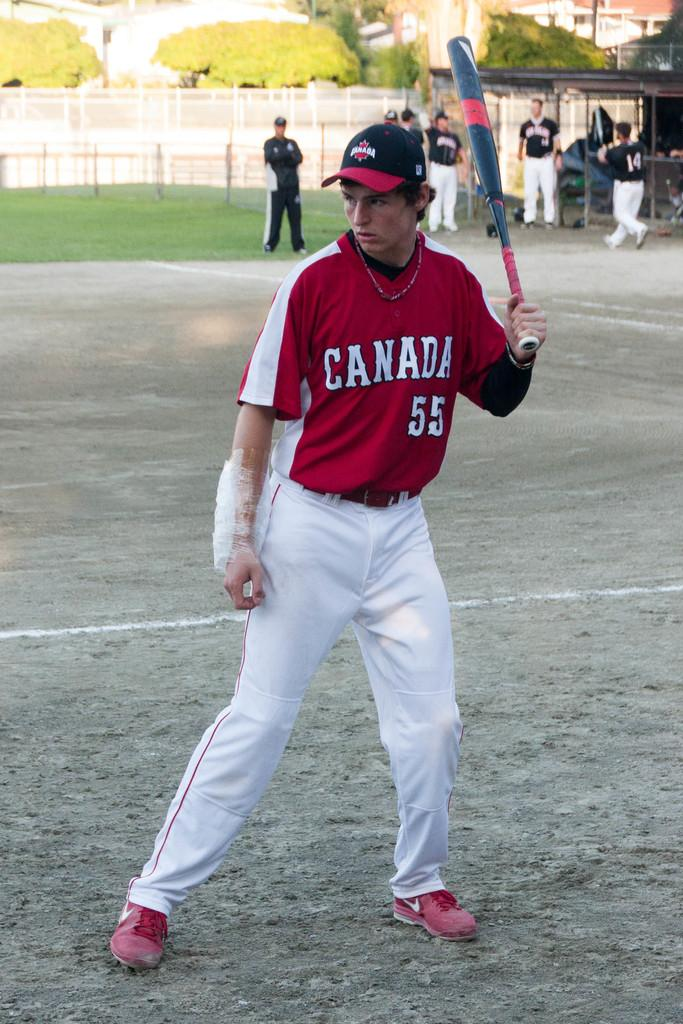<image>
Relay a brief, clear account of the picture shown. Player #55 for the Canada team gets ready to bat. 